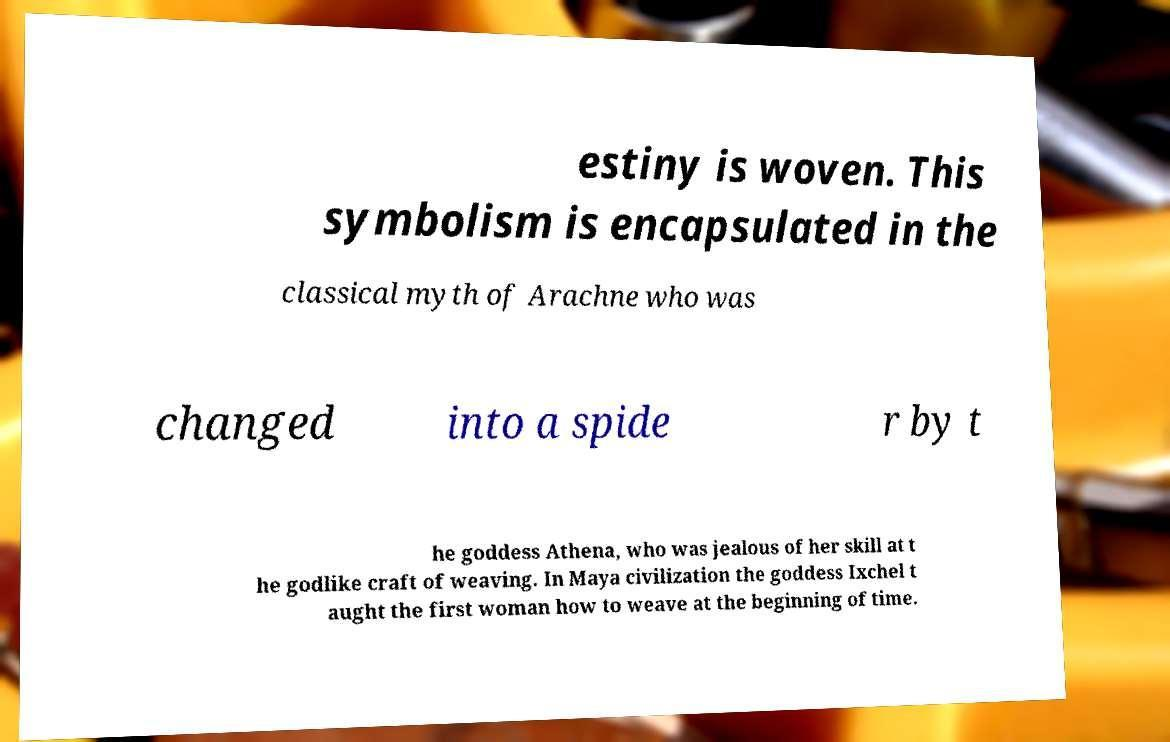There's text embedded in this image that I need extracted. Can you transcribe it verbatim? estiny is woven. This symbolism is encapsulated in the classical myth of Arachne who was changed into a spide r by t he goddess Athena, who was jealous of her skill at t he godlike craft of weaving. In Maya civilization the goddess Ixchel t aught the first woman how to weave at the beginning of time. 